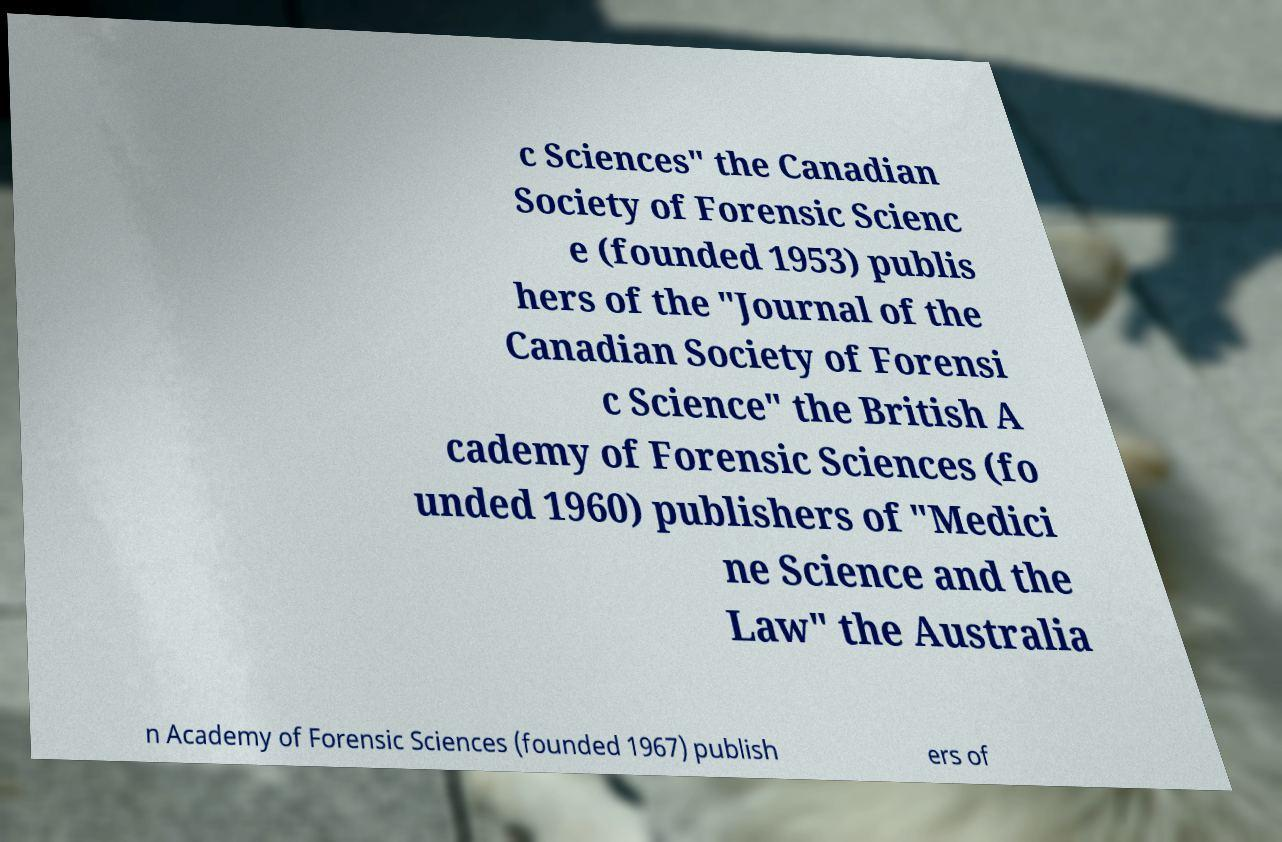For documentation purposes, I need the text within this image transcribed. Could you provide that? c Sciences" the Canadian Society of Forensic Scienc e (founded 1953) publis hers of the "Journal of the Canadian Society of Forensi c Science" the British A cademy of Forensic Sciences (fo unded 1960) publishers of "Medici ne Science and the Law" the Australia n Academy of Forensic Sciences (founded 1967) publish ers of 